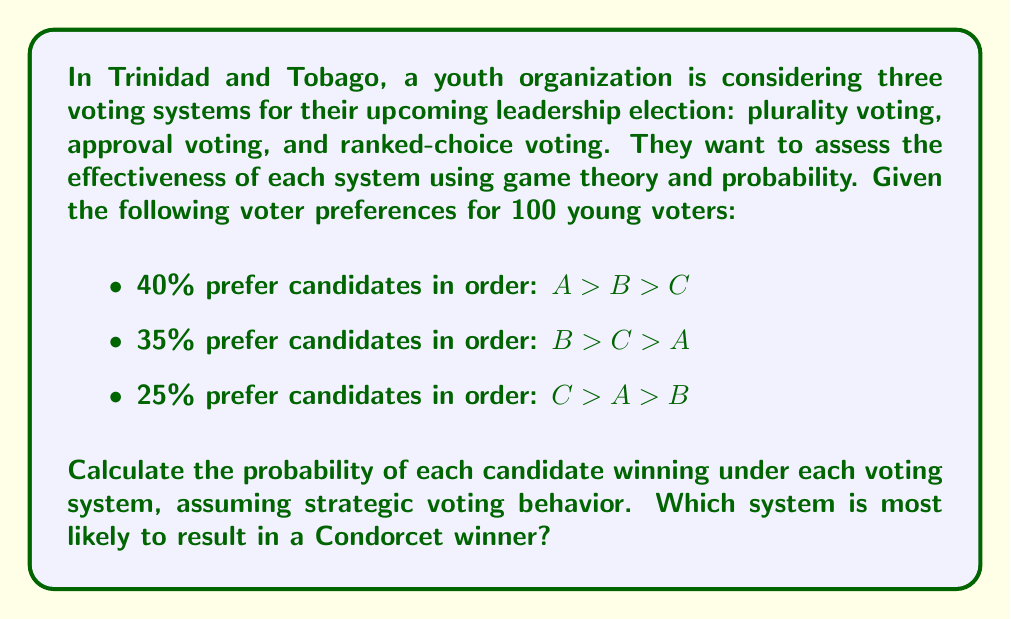Could you help me with this problem? Let's analyze each voting system:

1. Plurality Voting:
In this system, voters choose only their top preference. Assuming strategic voting:
Candidate A: 40%
Candidate B: 35%
Candidate C: 25%

Probability of winning:
$P(A) = 0.40$
$P(B) = 0.35$
$P(C) = 0.25$

2. Approval Voting:
Voters can approve multiple candidates. Assuming strategic behavior, voters might approve their top two choices:
Candidate A: 40% + 25% = 65%
Candidate B: 40% + 35% = 75%
Candidate C: 35% + 25% = 60%

Probability of winning:
$P(A) = 0.325$
$P(B) = 0.375$
$P(C) = 0.300$

3. Ranked-Choice Voting:
This system uses instant runoff. The candidate with the least first-choice votes is eliminated, and their votes are redistributed.

First round:
A: 40%, B: 35%, C: 25%

C is eliminated, and their votes go to A:
A: 40% + 25% = 65%
B: 35%

Probability of winning:
$P(A) = 0.65$
$P(B) = 0.35$
$P(C) = 0$

To determine the Condorcet winner, we compare head-to-head:
A vs B: A wins (65% > 35%)
A vs C: A wins (65% > 35%)
B vs C: B wins (75% > 25%)

Candidate A is the Condorcet winner, as they win against all other candidates in head-to-head comparisons.

The Ranked-Choice Voting system is most likely to result in the Condorcet winner, as it eliminates the spoiler effect and allows for a more accurate representation of voter preferences.
Answer: Probabilities of winning:
Plurality: $P(A) = 0.40$, $P(B) = 0.35$, $P(C) = 0.25$
Approval: $P(A) = 0.325$, $P(B) = 0.375$, $P(C) = 0.300$
Ranked-Choice: $P(A) = 0.65$, $P(B) = 0.35$, $P(C) = 0$

Ranked-Choice Voting is most likely to result in the Condorcet winner (Candidate A). 